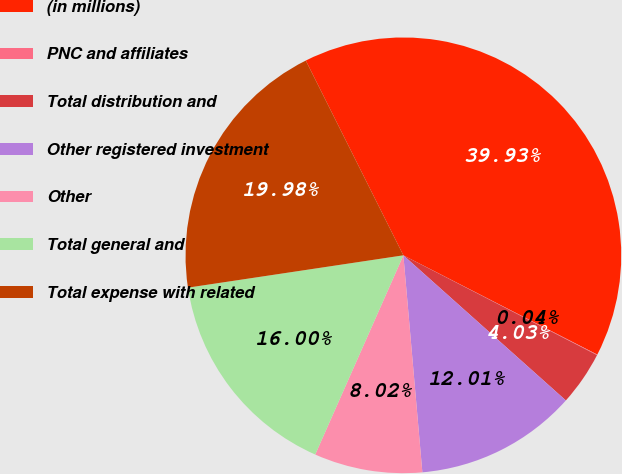Convert chart to OTSL. <chart><loc_0><loc_0><loc_500><loc_500><pie_chart><fcel>(in millions)<fcel>PNC and affiliates<fcel>Total distribution and<fcel>Other registered investment<fcel>Other<fcel>Total general and<fcel>Total expense with related<nl><fcel>39.93%<fcel>0.04%<fcel>4.03%<fcel>12.01%<fcel>8.02%<fcel>16.0%<fcel>19.98%<nl></chart> 